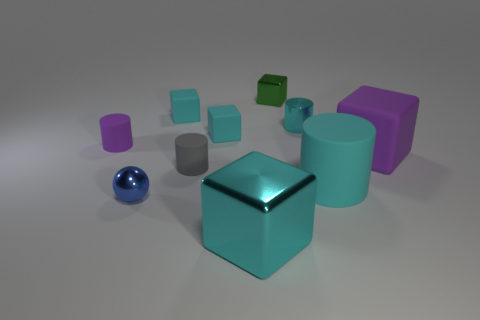Subtract all red spheres. How many cyan blocks are left? 3 Subtract 3 blocks. How many blocks are left? 2 Subtract all green cubes. How many cubes are left? 4 Subtract all large purple matte blocks. How many blocks are left? 4 Subtract all purple cubes. Subtract all yellow cylinders. How many cubes are left? 4 Subtract all balls. How many objects are left? 9 Subtract all cyan blocks. Subtract all big cyan matte things. How many objects are left? 6 Add 7 big cyan cubes. How many big cyan cubes are left? 8 Add 9 tiny purple things. How many tiny purple things exist? 10 Subtract 0 red spheres. How many objects are left? 10 